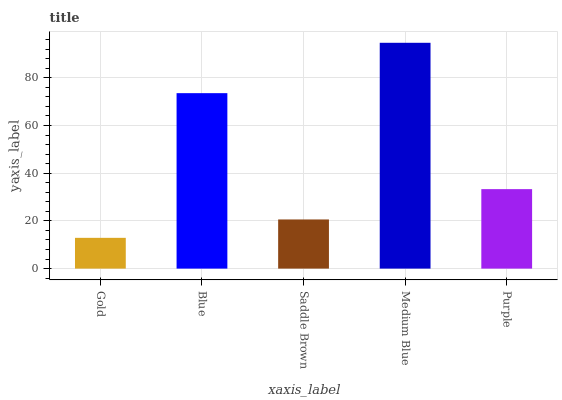Is Blue the minimum?
Answer yes or no. No. Is Blue the maximum?
Answer yes or no. No. Is Blue greater than Gold?
Answer yes or no. Yes. Is Gold less than Blue?
Answer yes or no. Yes. Is Gold greater than Blue?
Answer yes or no. No. Is Blue less than Gold?
Answer yes or no. No. Is Purple the high median?
Answer yes or no. Yes. Is Purple the low median?
Answer yes or no. Yes. Is Saddle Brown the high median?
Answer yes or no. No. Is Gold the low median?
Answer yes or no. No. 